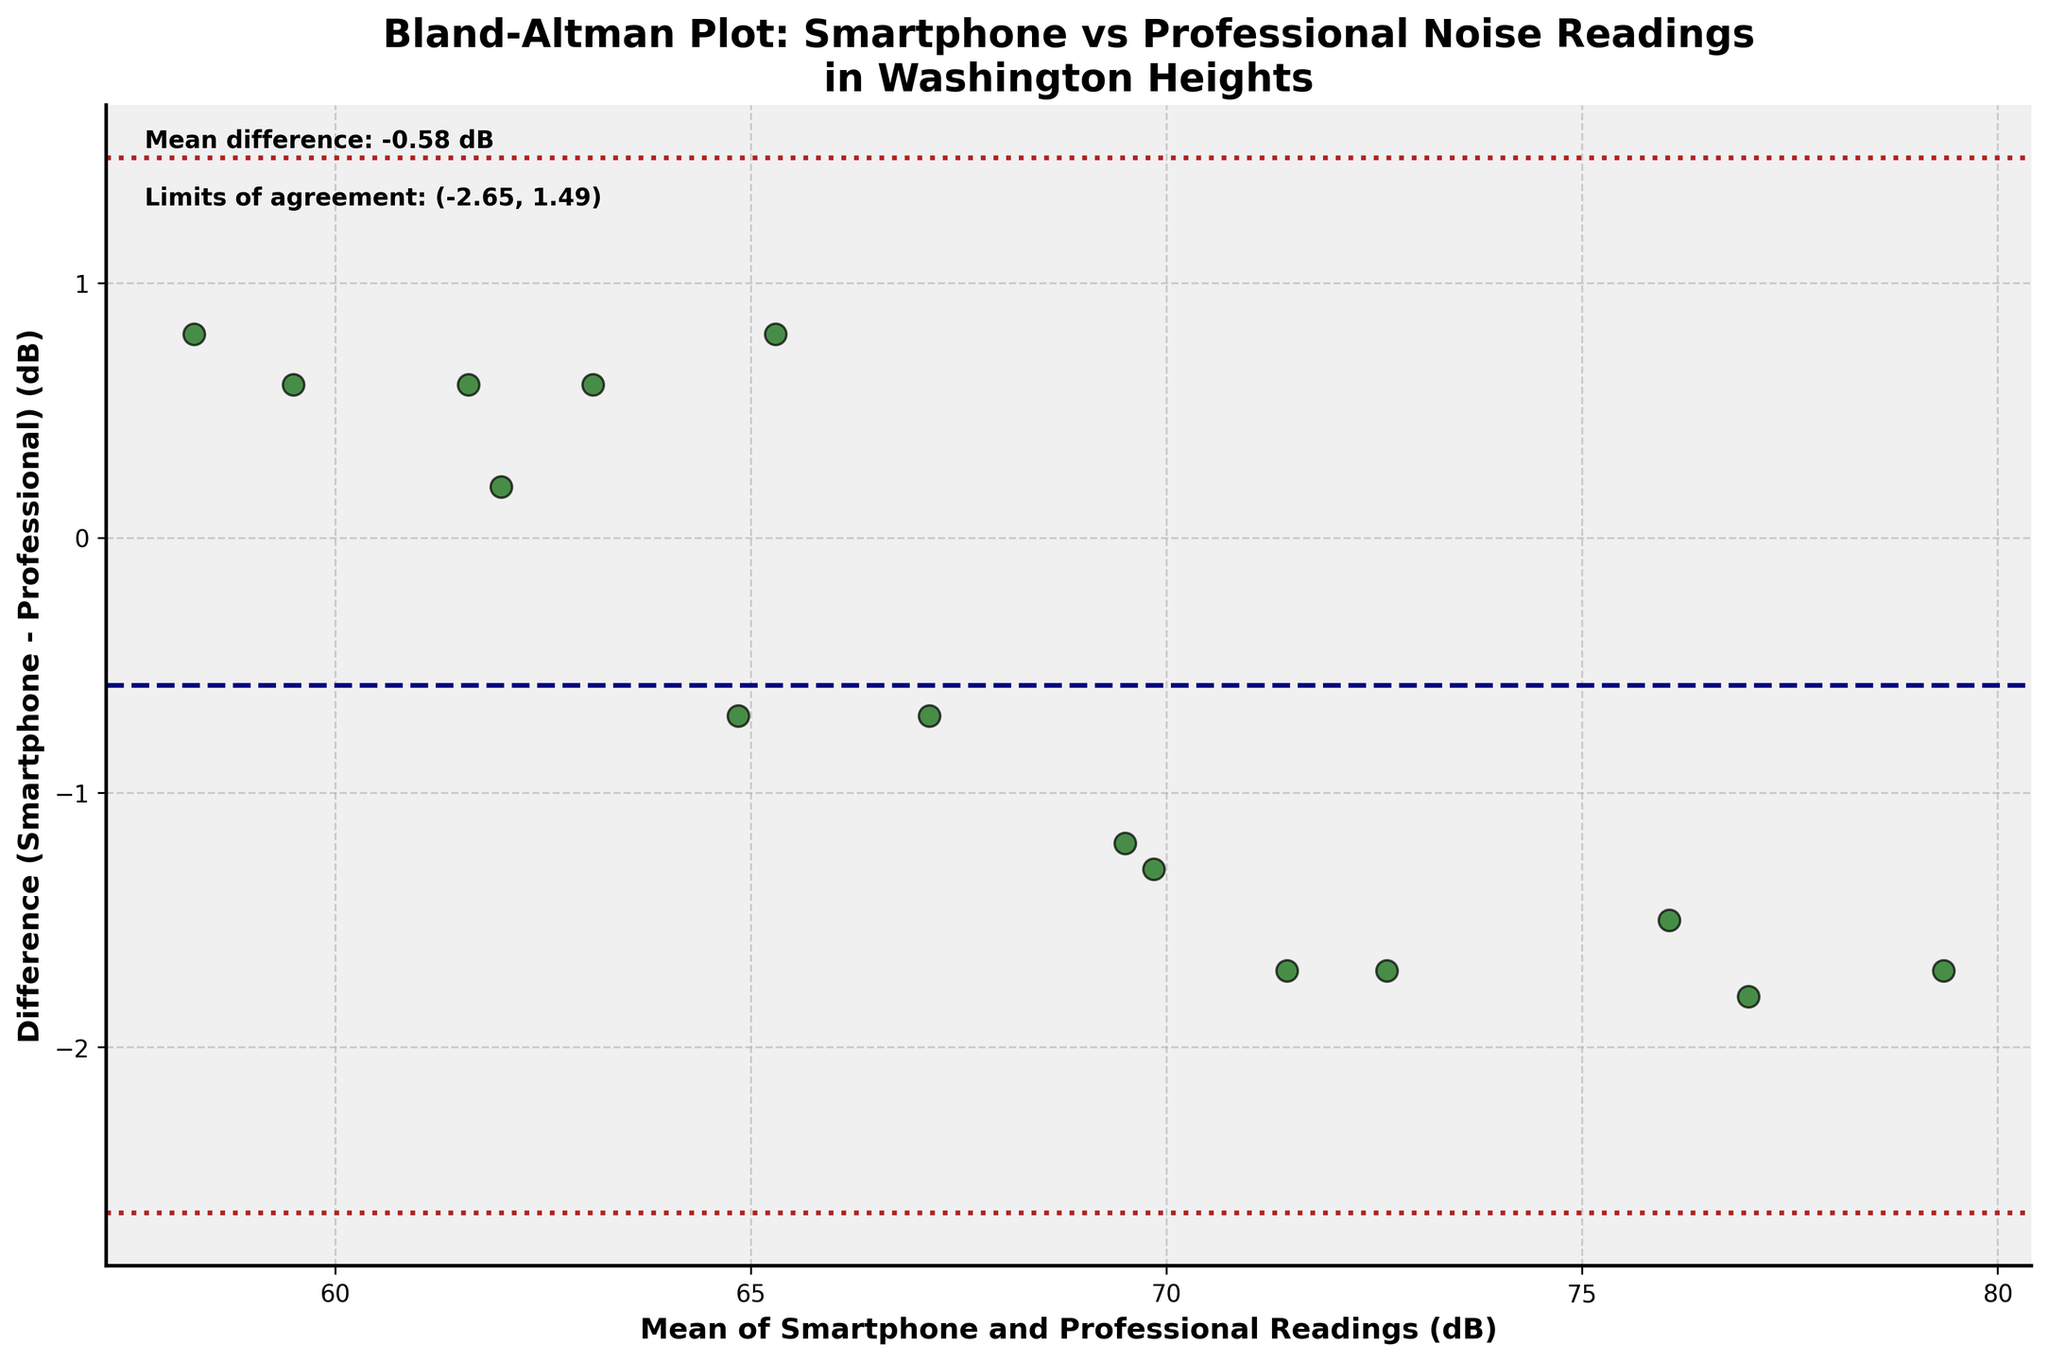What's the title of the plot? The title of the plot is located at the top and usually gives a brief description of what the graph is about. It reads: "Bland-Altman Plot: Smartphone vs Professional Noise Readings in Washington Heights."
Answer: Bland-Altman Plot: Smartphone vs Professional Noise Readings in Washington Heights What does the X-axis represent? The X-axis label specifies what the axis represents. In this plot, the X-axis is labeled as "Mean of Smartphone and Professional Readings (dB)," indicating it shows the mean of noise level readings from smartphone apps and professional decibel meters.
Answer: Mean of Smartphone and Professional Readings (dB) What is the mean difference between the readings? The mean difference is explicitly mentioned in the plot text. It states "Mean difference: 0.23 dB," indicating the average difference between smartphone and professional readings.
Answer: 0.23 dB How many data points are plotted? To determine the number of data points, look at the scatter plot's number of points. Each point represents a pair of readings, and there are 15 such points plotted.
Answer: 15 What are the limits of agreement? The limits of agreement are shown in the plot's text and are visualized with dotted lines. They are labeled as "Limits of agreement: (-2.00, 2.46)," providing the interval within which most differences between measurements lie.
Answer: (-2.00, 2.46) Which location has the largest positive difference between the smartphone and professional readings? Identify the data point with the highest positive difference on the Y-axis. "George Washington Bridge Pedestrian Path" at 1.30 dB difference is the highest.
Answer: George Washington Bridge Pedestrian Path Is there a trend in the differences as the mean of readings increases? Examine whether the differences (Y-axis) exhibit a pattern or remain random as the mean of readings (X-axis) increases. Here, the differences do not show a clear trend; they are scattered.
Answer: No trend What color and shape are the data points? Visualize the points' color and shape. The data points are dark green, circular markers with black edges.
Answer: Dark green circles with black edges How does the mean difference compare to the zero line? The mean difference is displayed as a dashed line on the plot, and we observe it's slightly above the zero line, indicating a small, positive average difference.
Answer: Slightly above For which location are the smartphone and professional readings the closest? The location with the difference nearest to zero on the Y-axis represents the closest readings. "Dyckman Farmhouse Museum" shows a very small difference of 0.6 dB.
Answer: Dyckman Farmhouse Museum 